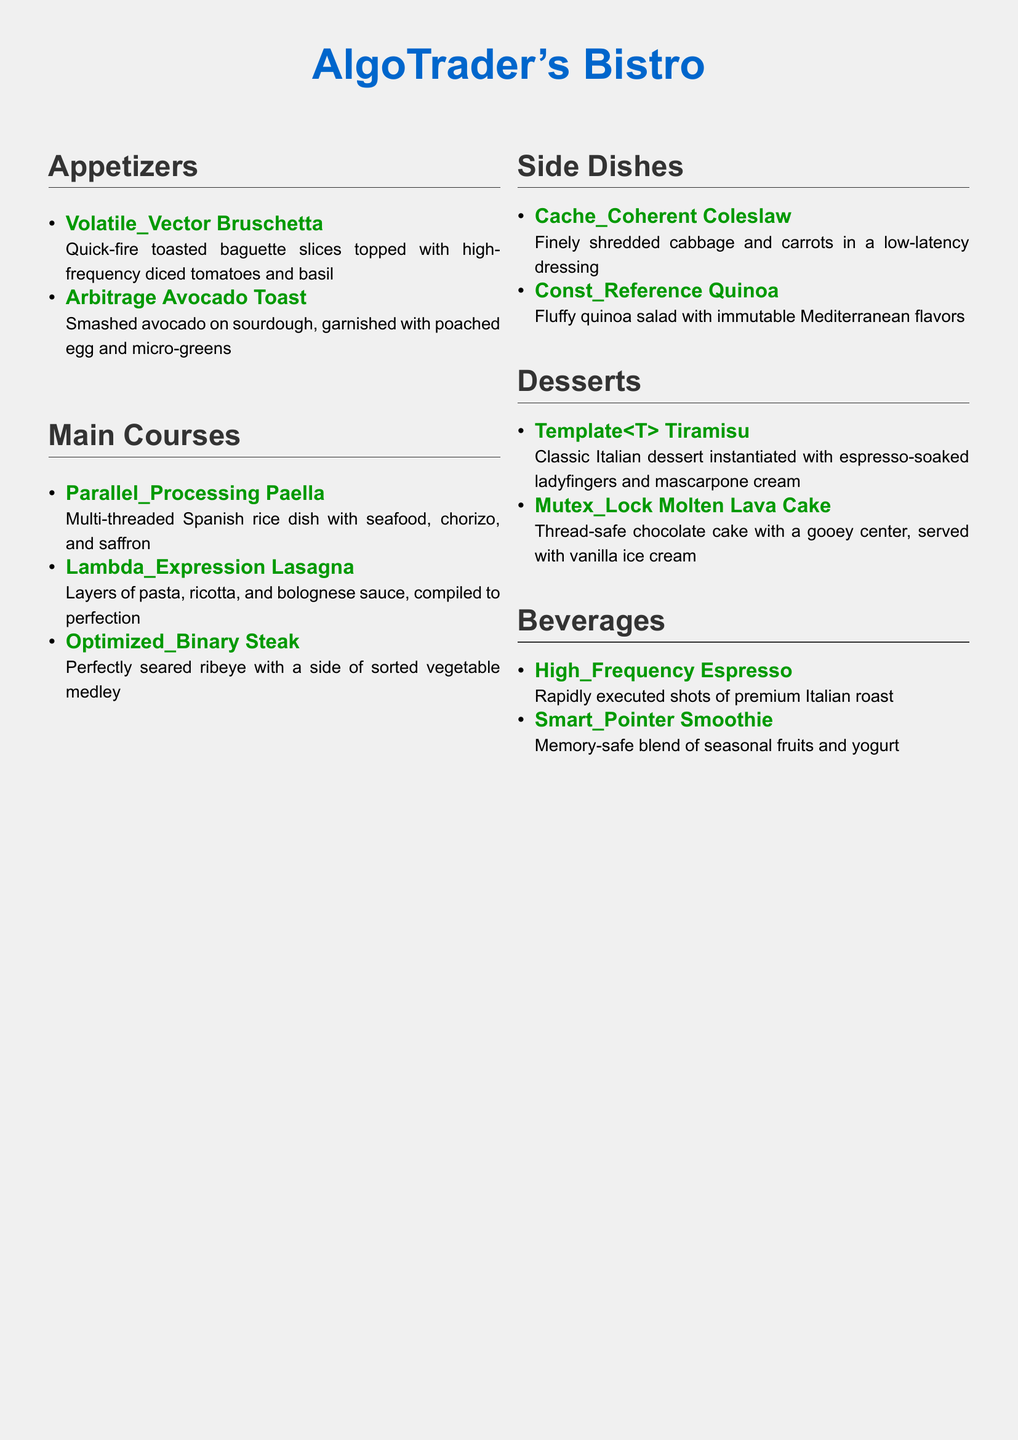What is the name of the restaurant? The restaurant's name is prominently displayed at the top of the document.
Answer: AlgoTrader's Bistro How many appetizers are listed? By counting the items in the Appetizers section, we find there are two.
Answer: 2 What dish features a saffron ingredient? The main course that includes saffron is mentioned specifically under its description.
Answer: Parallel Processing Paella What type of dessert is a classic Italian treat? The dessert section lists a classic Italian dessert, which is named accordingly.
Answer: Tiramisu Which beverage is described as rapidly executed? The description of the beverage highlights its quick preparation.
Answer: Espresso What is the main protein served with the Optimized Binary Steak? The menu explicitly describes the type of meat served with this dish.
Answer: Ribeye Which side dish has low-latency dressing? The document describes the side dish known for its dressing clearly.
Answer: Coleslaw What is the texture of the Mutex Lock Molten Lava Cake? The description of this dessert focuses on its unique texture clearly.
Answer: Gooey What does Smart Pointer Smoothie blend together? The beverage item highlights its ingredients directly in its description.
Answer: Seasonal fruits and yogurt 